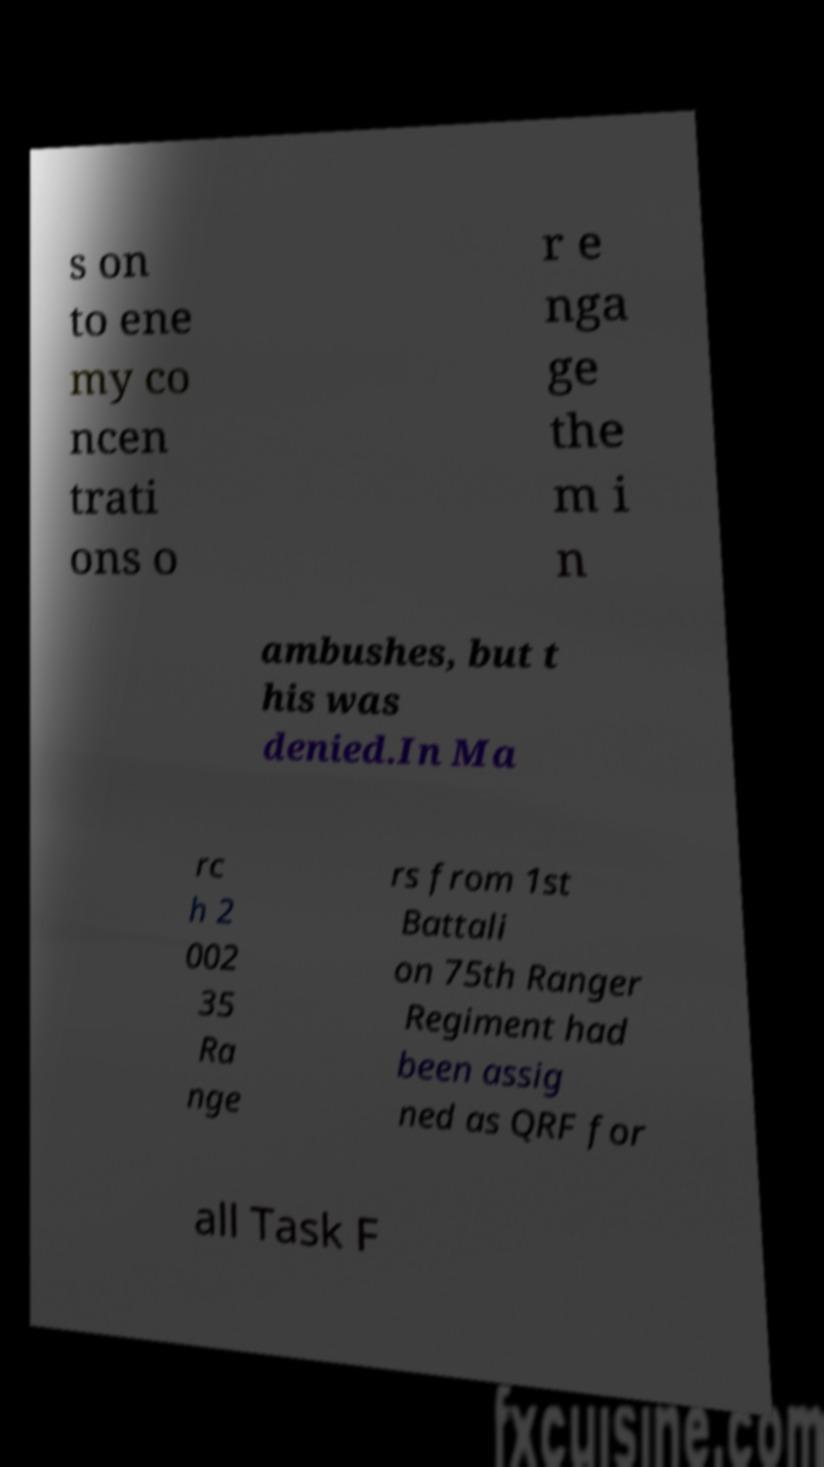Can you read and provide the text displayed in the image?This photo seems to have some interesting text. Can you extract and type it out for me? s on to ene my co ncen trati ons o r e nga ge the m i n ambushes, but t his was denied.In Ma rc h 2 002 35 Ra nge rs from 1st Battali on 75th Ranger Regiment had been assig ned as QRF for all Task F 